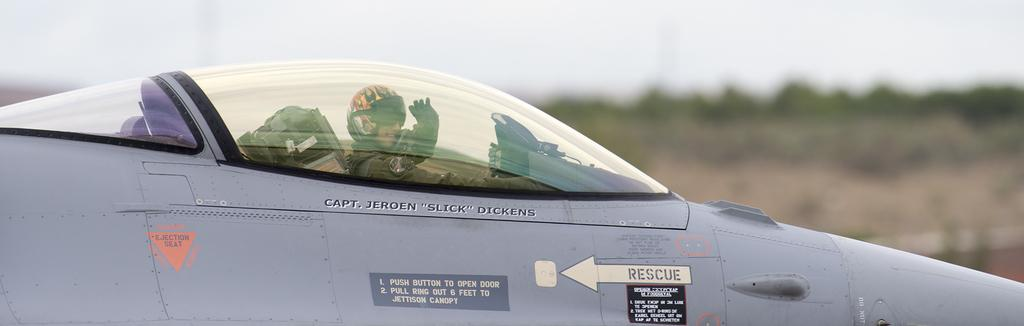Who or what is the main subject in the image? There is a person in the image. What is the person doing in the image? The person is sitting in an aircraft. What protective gear is the person wearing in the image? The person is wearing a helmet. What type of desk can be seen in the image? There is no desk present in the image. How many chickens are visible in the image? There are no chickens present in the image. 